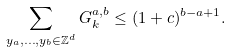Convert formula to latex. <formula><loc_0><loc_0><loc_500><loc_500>\sum _ { y _ { a } , \dots , y _ { b } \in \mathbb { Z } ^ { d } } G _ { k } ^ { a , b } \leq ( 1 + c ) ^ { b - a + 1 } .</formula> 